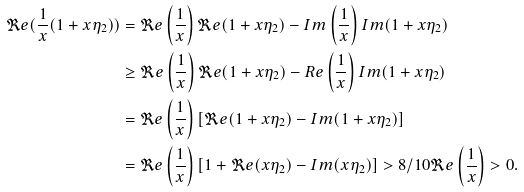Convert formula to latex. <formula><loc_0><loc_0><loc_500><loc_500>\Re e ( \frac { 1 } { x } ( 1 + x \eta _ { 2 } ) ) & = \Re e \left ( \frac { 1 } { x } \right ) \Re e ( 1 + x \eta _ { 2 } ) - I m \left ( \frac { 1 } { x } \right ) I m ( 1 + x \eta _ { 2 } ) \\ & \geq \Re e \left ( \frac { 1 } { x } \right ) \Re e ( 1 + x \eta _ { 2 } ) - R e \left ( \frac { 1 } { x } \right ) I m ( 1 + x \eta _ { 2 } ) \\ & = \Re e \left ( \frac { 1 } { x } \right ) [ \Re e ( 1 + x \eta _ { 2 } ) - I m ( 1 + x \eta _ { 2 } ) ] \\ & = \Re e \left ( \frac { 1 } { x } \right ) [ 1 + \Re e ( x \eta _ { 2 } ) - I m ( x \eta _ { 2 } ) ] > 8 / 1 0 \Re e \left ( \frac { 1 } { x } \right ) > 0 .</formula> 